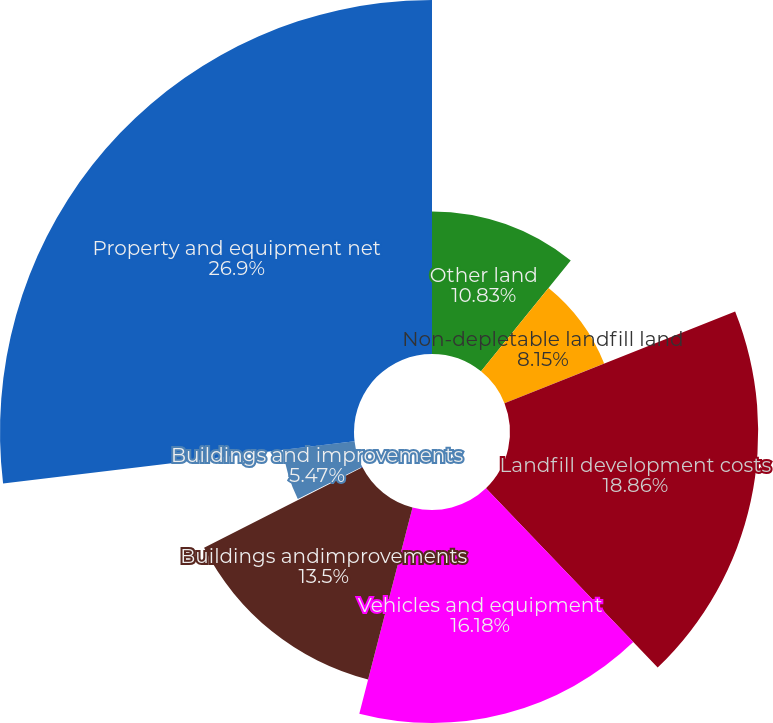Convert chart. <chart><loc_0><loc_0><loc_500><loc_500><pie_chart><fcel>Other land<fcel>Non-depletable landfill land<fcel>Landfill development costs<fcel>Vehicles and equipment<fcel>Buildings andimprovements<fcel>Construction-in-progress -<fcel>Buildings and improvements<fcel>Property and equipment net<nl><fcel>10.83%<fcel>8.15%<fcel>18.86%<fcel>16.18%<fcel>13.5%<fcel>0.11%<fcel>5.47%<fcel>26.9%<nl></chart> 